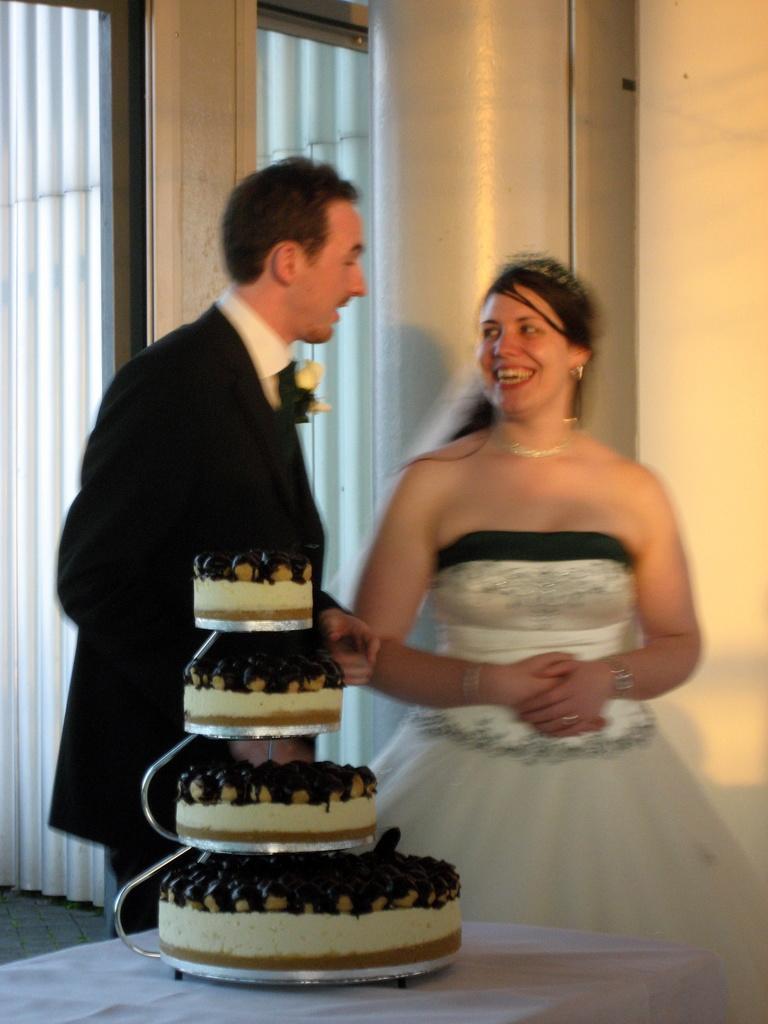Could you give a brief overview of what you see in this image? This picture seems to be clicked inside the room. In the foreground we can see the cakes and some other items are placed on the top of the table and we can see a woman wearing white color dress, smiling and standing and we can see a man wearing suit and standing. In the background we can see the wall, curtain and some other objects. 